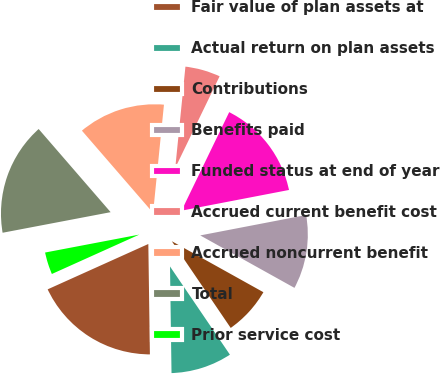Convert chart. <chart><loc_0><loc_0><loc_500><loc_500><pie_chart><fcel>Fair value of plan assets at<fcel>Actual return on plan assets<fcel>Contributions<fcel>Benefits paid<fcel>Funded status at end of year<fcel>Accrued current benefit cost<fcel>Accrued noncurrent benefit<fcel>Total<fcel>Prior service cost<nl><fcel>18.49%<fcel>9.27%<fcel>7.42%<fcel>11.11%<fcel>14.8%<fcel>5.58%<fcel>12.95%<fcel>16.64%<fcel>3.74%<nl></chart> 